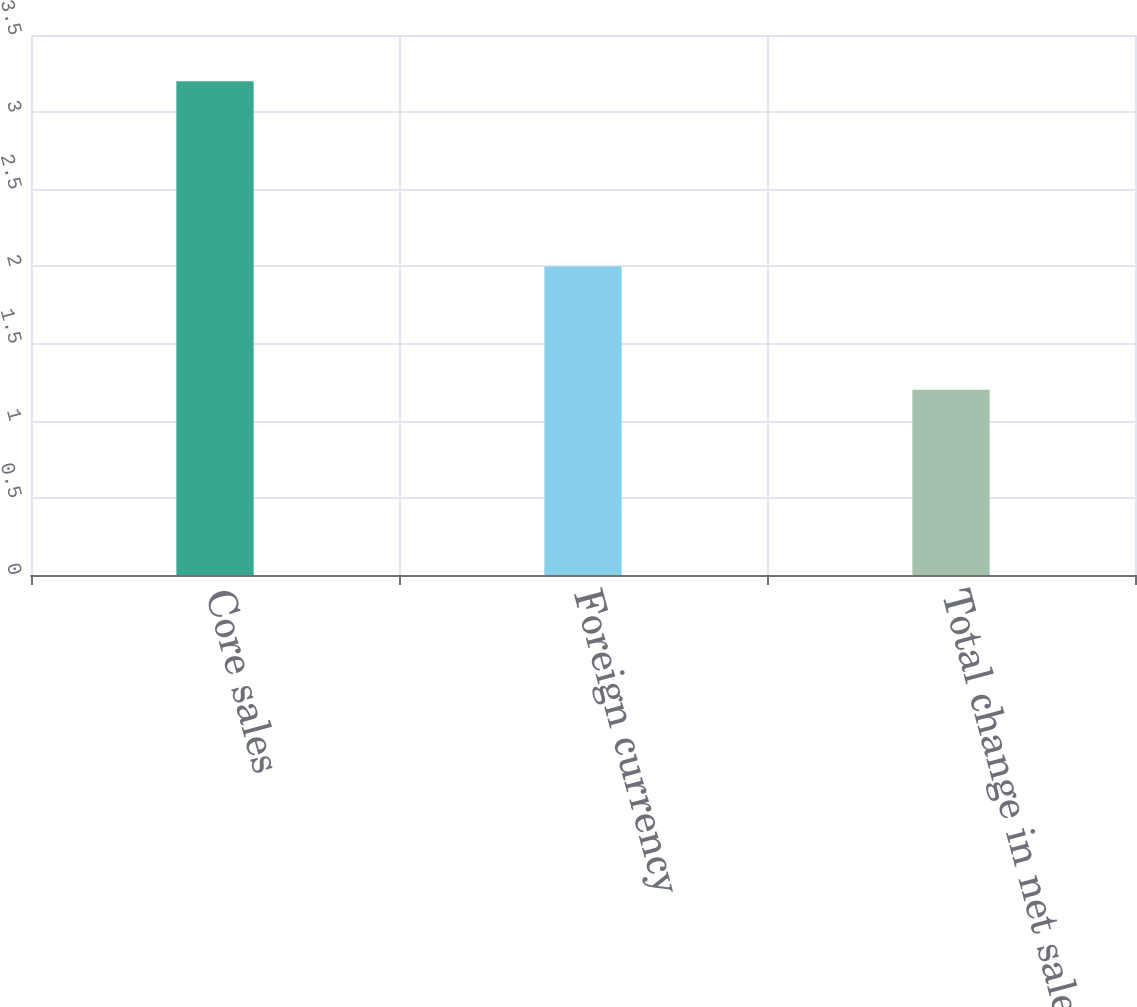<chart> <loc_0><loc_0><loc_500><loc_500><bar_chart><fcel>Core sales<fcel>Foreign currency<fcel>Total change in net sales<nl><fcel>3.2<fcel>2<fcel>1.2<nl></chart> 